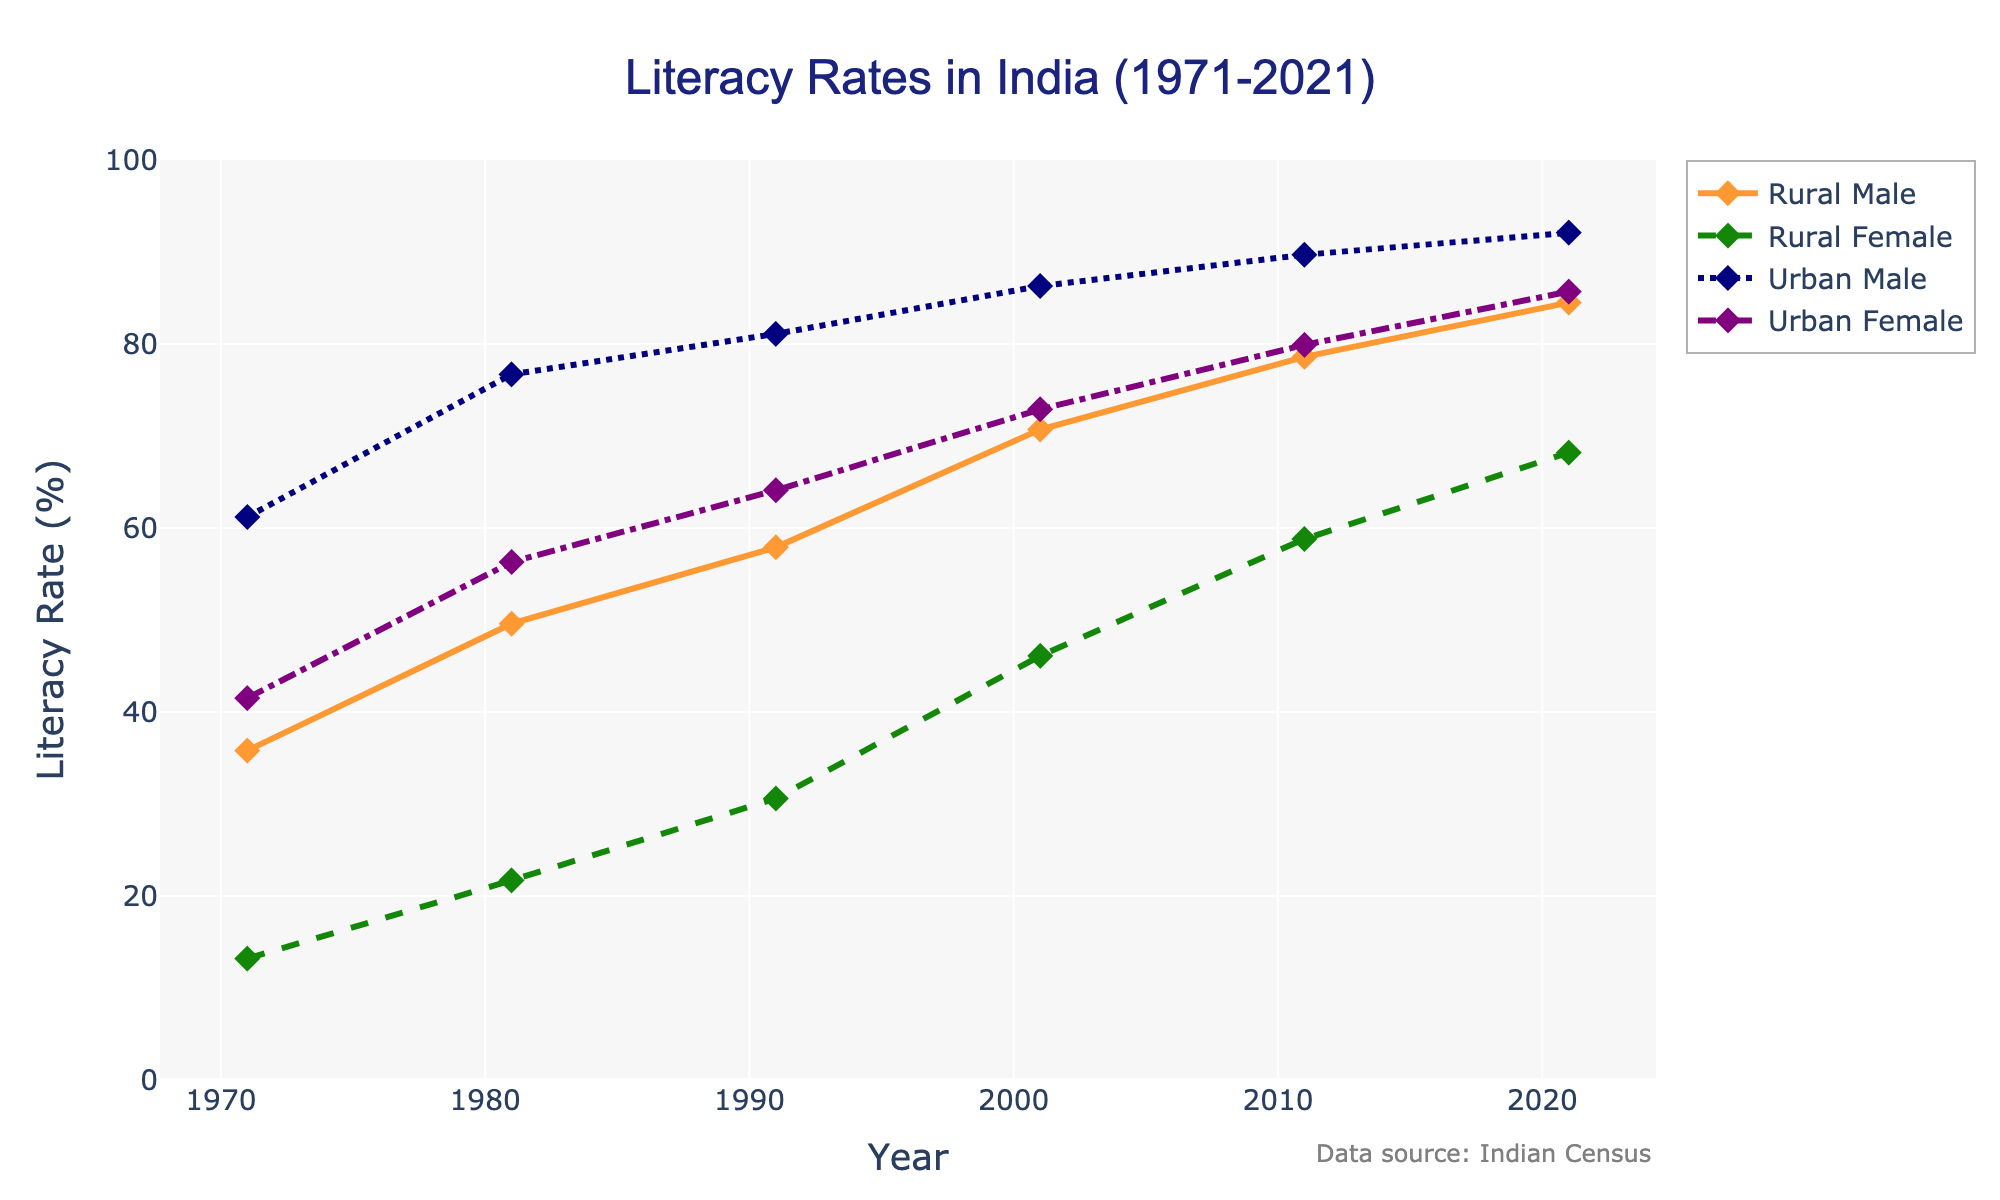Which gender had the lowest literacy rate in 1971? In 1971, the chart shows the literacy rates for rural males, rural females, urban males, and urban females. The lowest literacy rate among these groups was rural female at 13.2%.
Answer: Rural female How much did the literacy rate for rural females improve from 1971 to 2021? The literacy rate for rural females in 1971 was 13.2% and in 2021 it was 68.2%. The improvement is calculated as 68.2% - 13.2% = 55%.
Answer: 55% Compare the literacy rates of urban males and rural males in 2021. Which group had higher literacy rates? In 2021, the literacy rate for urban males was 92.1%, while for rural males it was 84.5%. Urban males had a higher literacy rate compared to rural males.
Answer: Urban males What is the average literacy rate for urban females over the years provided (1971, 1981, 1991, 2001, 2011, 2021)? Literacy rates for urban females are 41.5%, 56.3%, 64.1%, 72.9%, 79.9%, and 85.7%. The average is calculated as (41.5 + 56.3 + 64.1 + 72.9 + 79.9 + 85.7) / 6 ≈ 66.73%.
Answer: 66.73% Which group saw the highest increase in literacy rate from 1971 to 2021? Calculate the increase for each group: 
Rural Male: 84.5% - 35.8% = 48.7%
Rural Female: 68.2% - 13.2% = 55%
Urban Male: 92.1% - 61.2% = 30.9%
Urban Female: 85.7% - 41.5% = 44.2%
Rural females saw the highest increase of 55%.
Answer: Rural females By how much did the literacy rate of rural males exceed that of rural females in 2001? In 2001, the literacy rate for rural males was 70.7% and for rural females, it was 46.1%. The difference is calculated as 70.7% - 46.1% = 24.6%.
Answer: 24.6% What trend can be observed in the literacy rates of urban females from 1971 to 2021? Examining the data points for urban females (41.5%, 56.3%, 64.1%, 72.9%, 79.9%, and 85.7%), we can observe that the literacy rate shows a steadily increasing trend across all years from 1971 to 2021.
Answer: Increasing trend 